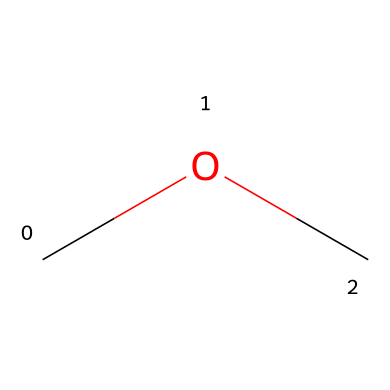What is the molecular formula of this compound? The SMILES representation "COC" indicates the presence of two carbon atoms (C) and six hydrogen atoms (H) along with one oxygen atom (O), leading to the molecular formula being C2H6O.
Answer: C2H6O How many atoms are present in dimethyl ether? The molecular formula C2H6O consists of 2 carbon atoms, 6 hydrogen atoms, and 1 oxygen atom. Adding these together gives a total of 9 atoms.
Answer: 9 What type of chemical is dimethyl ether? Dimethyl ether is classified as an ether due to its characteristic structure that includes an oxygen atom single-bonded to two alkyl groups.
Answer: ether What is the functional group present in dimethyl ether? The presence of the oxygen atom between the two carbon atoms indicates that this compound has an ether functional group.
Answer: ether How many bonds are formed between the atoms in dimethyl ether? In the structure represented by COC, there are two carbon-oxygen single bonds and four carbon-hydrogen single bonds, which sums up to a total of six bonds.
Answer: 6 Is dimethyl ether a gas, liquid, or solid at room temperature? Dimethyl ether has a low boiling point of around -24 degrees Celsius, indicating that it is a gas at room temperature under standard conditions.
Answer: gas What is the primary use of dimethyl ether? Dimethyl ether is commonly used as a propellant in aerosol sprays, particularly for applications like muscle pain relief.
Answer: propellant 